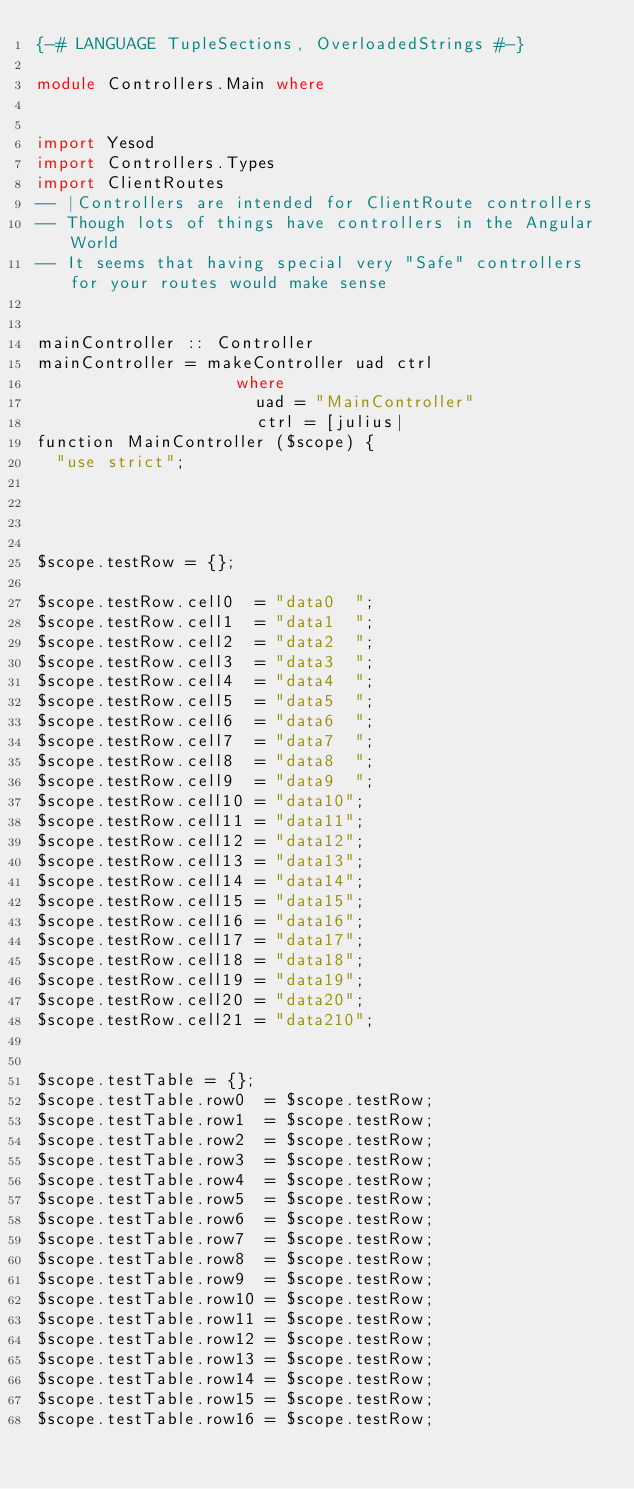Convert code to text. <code><loc_0><loc_0><loc_500><loc_500><_Haskell_>{-# LANGUAGE TupleSections, OverloadedStrings #-}

module Controllers.Main where


import Yesod 
import Controllers.Types
import ClientRoutes
-- |Controllers are intended for ClientRoute controllers
-- Though lots of things have controllers in the Angular World
-- It seems that having special very "Safe" controllers for your routes would make sense


mainController :: Controller
mainController = makeController uad ctrl 
                    where 
                      uad = "MainController"
                      ctrl = [julius|
function MainController ($scope) {
  "use strict";                                




$scope.testRow = {};

$scope.testRow.cell0  = "data0  "; 
$scope.testRow.cell1  = "data1  "; 
$scope.testRow.cell2  = "data2  "; 
$scope.testRow.cell3  = "data3  "; 
$scope.testRow.cell4  = "data4  "; 
$scope.testRow.cell5  = "data5  "; 
$scope.testRow.cell6  = "data6  "; 
$scope.testRow.cell7  = "data7  "; 
$scope.testRow.cell8  = "data8  "; 
$scope.testRow.cell9  = "data9  ";   
$scope.testRow.cell10 = "data10";
$scope.testRow.cell11 = "data11";
$scope.testRow.cell12 = "data12";
$scope.testRow.cell13 = "data13";
$scope.testRow.cell14 = "data14";
$scope.testRow.cell15 = "data15";
$scope.testRow.cell16 = "data16";
$scope.testRow.cell17 = "data17";
$scope.testRow.cell18 = "data18";
$scope.testRow.cell19 = "data19";
$scope.testRow.cell20 = "data20";
$scope.testRow.cell21 = "data210";


$scope.testTable = {};
$scope.testTable.row0  = $scope.testRow;         
$scope.testTable.row1  = $scope.testRow;         
$scope.testTable.row2  = $scope.testRow;         
$scope.testTable.row3  = $scope.testRow;         
$scope.testTable.row4  = $scope.testRow;         
$scope.testTable.row5  = $scope.testRow;         
$scope.testTable.row6  = $scope.testRow;         
$scope.testTable.row7  = $scope.testRow;         
$scope.testTable.row8  = $scope.testRow;         
$scope.testTable.row9  = $scope.testRow;         
$scope.testTable.row10 = $scope.testRow;          
$scope.testTable.row11 = $scope.testRow;          
$scope.testTable.row12 = $scope.testRow;          
$scope.testTable.row13 = $scope.testRow;          
$scope.testTable.row14 = $scope.testRow;          
$scope.testTable.row15 = $scope.testRow;          
$scope.testTable.row16 = $scope.testRow;          </code> 